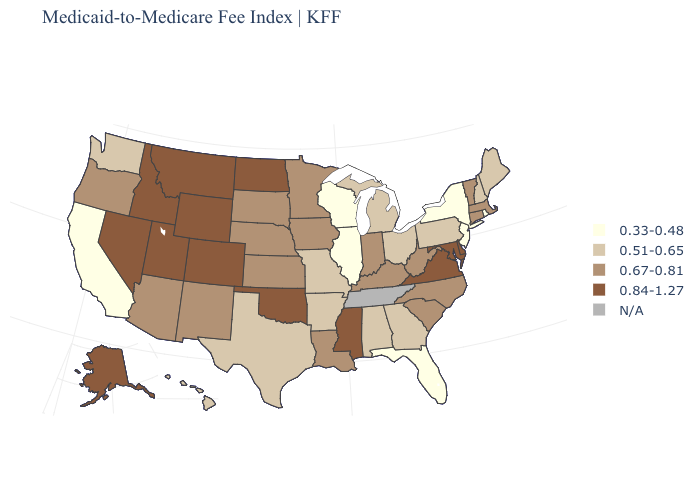Among the states that border Wisconsin , does Illinois have the lowest value?
Short answer required. Yes. Does Missouri have the lowest value in the MidWest?
Give a very brief answer. No. Name the states that have a value in the range N/A?
Keep it brief. Tennessee. Does the first symbol in the legend represent the smallest category?
Keep it brief. Yes. What is the lowest value in the USA?
Write a very short answer. 0.33-0.48. What is the highest value in the MidWest ?
Write a very short answer. 0.84-1.27. What is the value of Utah?
Give a very brief answer. 0.84-1.27. What is the highest value in states that border Maine?
Give a very brief answer. 0.51-0.65. Does North Dakota have the highest value in the MidWest?
Answer briefly. Yes. Does Florida have the lowest value in the South?
Concise answer only. Yes. Name the states that have a value in the range 0.51-0.65?
Short answer required. Alabama, Arkansas, Georgia, Hawaii, Maine, Michigan, Missouri, New Hampshire, Ohio, Pennsylvania, Texas, Washington. Which states have the lowest value in the West?
Keep it brief. California. What is the lowest value in the USA?
Short answer required. 0.33-0.48. What is the value of North Dakota?
Quick response, please. 0.84-1.27. What is the highest value in the USA?
Concise answer only. 0.84-1.27. 